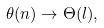Convert formula to latex. <formula><loc_0><loc_0><loc_500><loc_500>\theta ( n ) \rightarrow \Theta ( l ) ,</formula> 